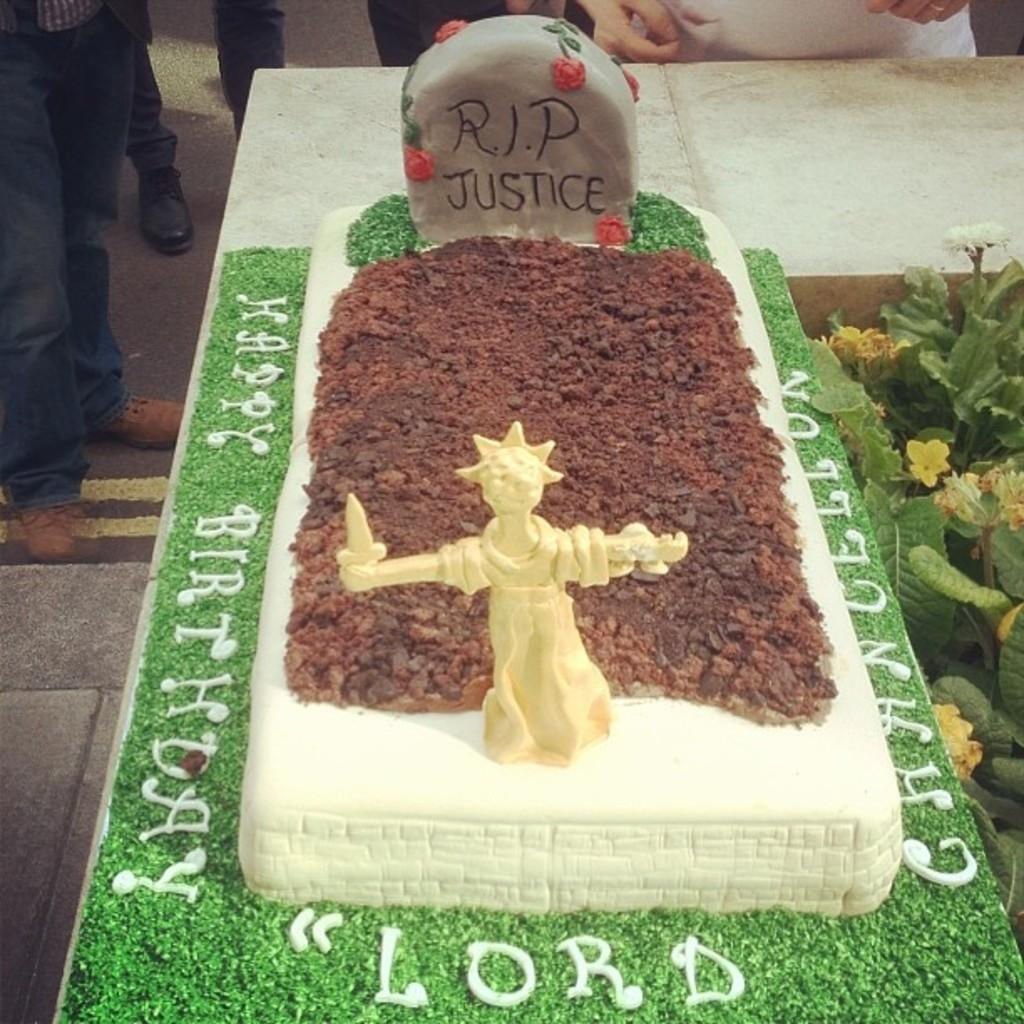What is the main subject of the image? There is a grave in the image. What can be seen on the grave? There is soil on the grave, and there is an idol on it. What is present on the left side of the image? There are flowers and plants on the left side of the image. What can be seen in the background of the image? There are people standing in the background of the image. How does the mountain in the image affect the sense of smell? There is no mountain present in the image, so it cannot affect the sense of smell. 